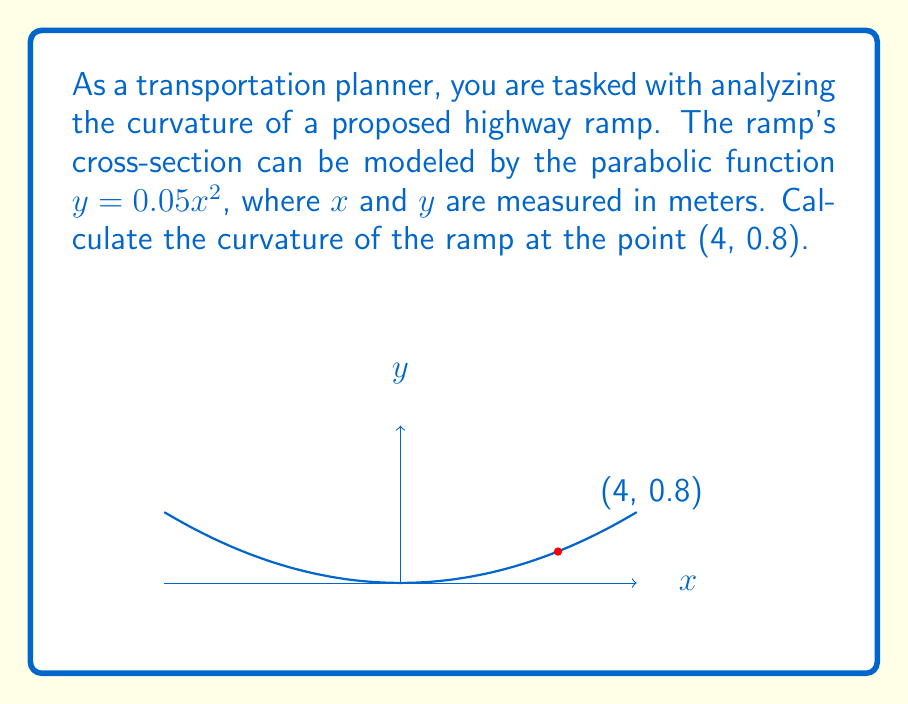Can you solve this math problem? To calculate the curvature of the parabolic ramp, we'll follow these steps:

1) The formula for curvature $K$ of a function $y = f(x)$ at a point $(x, y)$ is:

   $$K = \frac{|f''(x)|}{(1 + [f'(x)]^2)^{3/2}}$$

2) First, we need to find $f'(x)$ and $f''(x)$:
   
   $f(x) = 0.05x^2$
   $f'(x) = 0.1x$
   $f''(x) = 0.1$

3) At the point (4, 0.8), $x = 4$. Let's calculate $f'(4)$:
   
   $f'(4) = 0.1(4) = 0.4$

4) Now we can plug these values into the curvature formula:

   $$K = \frac{|0.1|}{(1 + [0.4]^2)^{3/2}}$$

5) Simplify:
   
   $$K = \frac{0.1}{(1 + 0.16)^{3/2}} = \frac{0.1}{1.16^{3/2}}$$

6) Calculate the final value:
   
   $$K \approx 0.0781 \text{ m}^{-1}$$

This curvature value represents the reciprocal of the radius of the osculating circle at the given point on the ramp.
Answer: $0.0781 \text{ m}^{-1}$ 